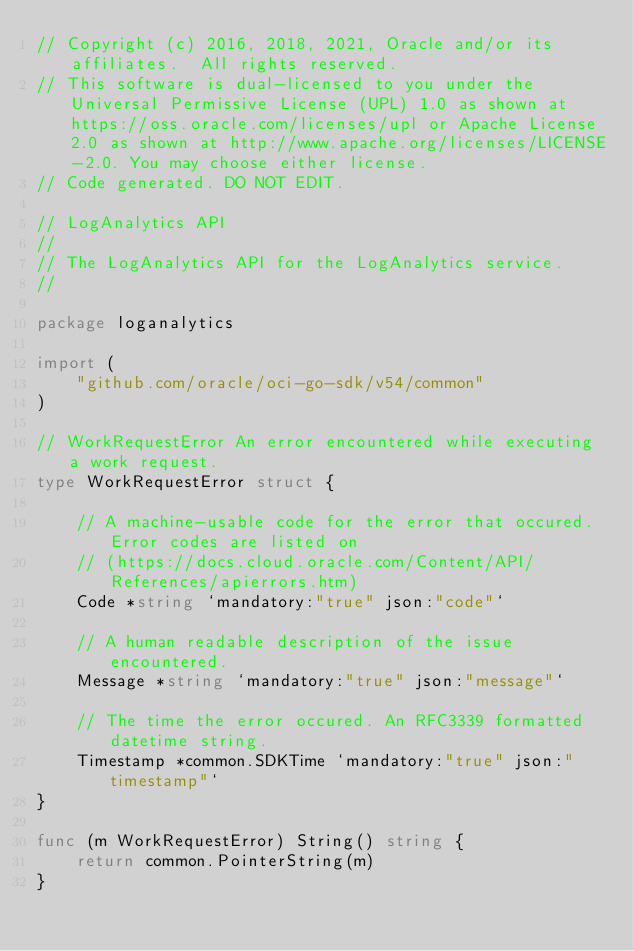<code> <loc_0><loc_0><loc_500><loc_500><_Go_>// Copyright (c) 2016, 2018, 2021, Oracle and/or its affiliates.  All rights reserved.
// This software is dual-licensed to you under the Universal Permissive License (UPL) 1.0 as shown at https://oss.oracle.com/licenses/upl or Apache License 2.0 as shown at http://www.apache.org/licenses/LICENSE-2.0. You may choose either license.
// Code generated. DO NOT EDIT.

// LogAnalytics API
//
// The LogAnalytics API for the LogAnalytics service.
//

package loganalytics

import (
	"github.com/oracle/oci-go-sdk/v54/common"
)

// WorkRequestError An error encountered while executing a work request.
type WorkRequestError struct {

	// A machine-usable code for the error that occured. Error codes are listed on
	// (https://docs.cloud.oracle.com/Content/API/References/apierrors.htm)
	Code *string `mandatory:"true" json:"code"`

	// A human readable description of the issue encountered.
	Message *string `mandatory:"true" json:"message"`

	// The time the error occured. An RFC3339 formatted datetime string.
	Timestamp *common.SDKTime `mandatory:"true" json:"timestamp"`
}

func (m WorkRequestError) String() string {
	return common.PointerString(m)
}
</code> 